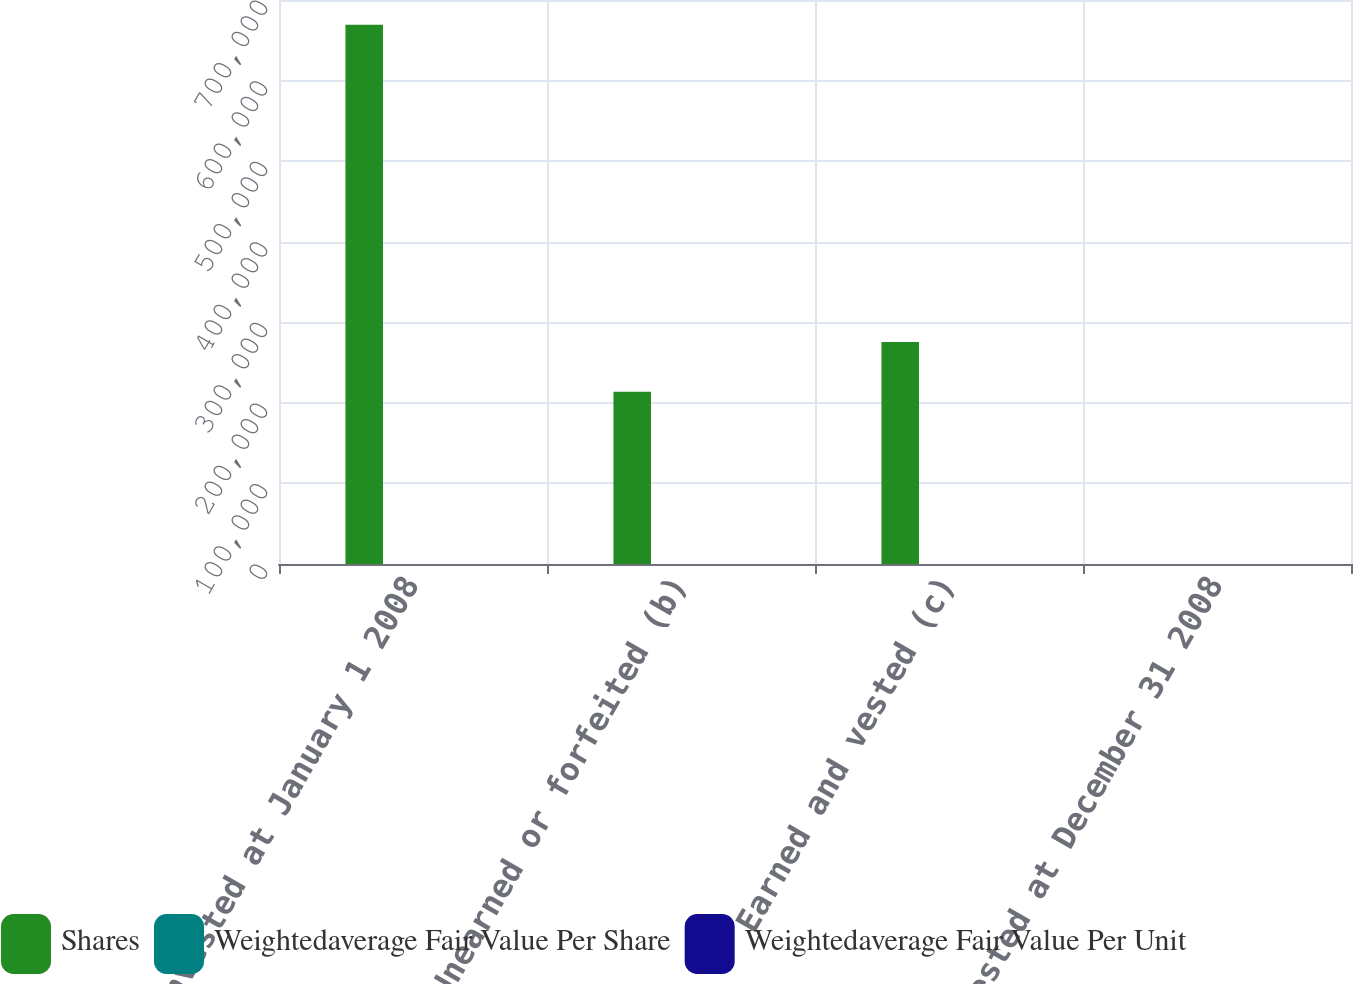Convert chart. <chart><loc_0><loc_0><loc_500><loc_500><stacked_bar_chart><ecel><fcel>Nonvested at January 1 2008<fcel>Unearned or forfeited (b)<fcel>Earned and vested (c)<fcel>Nonvested at December 31 2008<nl><fcel>Shares<fcel>669403<fcel>213854<fcel>275419<fcel>49.37<nl><fcel>Weightedaverage Fair Value Per Share<fcel>57.88<fcel>55.82<fcel>49.37<fcel>43.28<nl><fcel>Weightedaverage Fair Value Per Unit<fcel>46.23<fcel>48.19<fcel>44.05<fcel>47.46<nl></chart> 